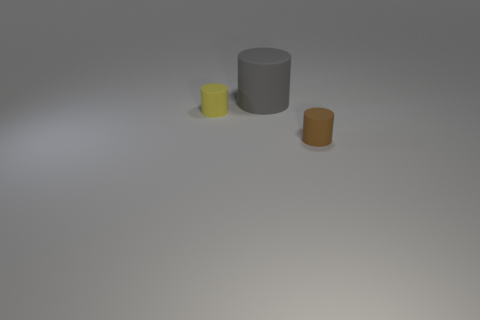Do the big gray matte thing and the small brown object have the same shape? The large gray object and the small brown object both appear to have cylindrical shapes with circular bases. However, they differ in size and color, with the gray one being notably larger and featuring a matte texture, while the brown one is smaller, with a different surface finish. 